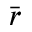Convert formula to latex. <formula><loc_0><loc_0><loc_500><loc_500>\bar { r }</formula> 